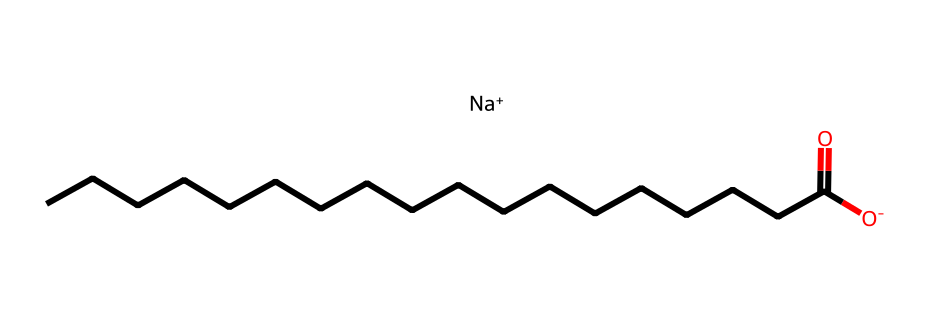What is the main anion present in this lye soap molecule? The structure features a sodium ion (Na+) paired with a negatively charged carboxylate group (O-), specifically indicated by the O- at the start of the carbon chain, making the carboxylate the main anion.
Answer: carboxylate How many carbon atoms are in the fatty acid chain of this lye soap? The chemical structure shows a long hydrocarbon chain denoted by "CCCCCCCCCCCCCCCCC," which contains 17 carbon atoms, as each "C" accounts for one carbon atom in the chain.
Answer: 17 What type of bond connects the sodium ion to the acid component? The sodium ion (Na+) and the carboxylate group form an ionic bond due to the interaction between the positively charged sodium and the negatively charged oxygen, typical of lye soaps that result from saponification.
Answer: ionic bond Is this molecule primarily hydrophobic or hydrophilic? The long hydrocarbon chain suggests that the structure is largely hydrophobic, while the presence of the carboxylate end (O-) introduces a hydrophilic aspect, but the dominant character is hydrophobic due to the length of the carbon chain.
Answer: hydrophobic What functional group is responsible for the soap's cleaning properties? The carboxylate group (-COO-) is the functional group that provides the surfactant properties essential for the cleaning action in lye soap, allowing it to emulsify oils and grease.
Answer: carboxylate group 